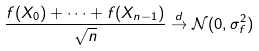<formula> <loc_0><loc_0><loc_500><loc_500>\frac { f ( X _ { 0 } ) + \dots + f ( X _ { n - 1 } ) } { \sqrt { n } } \stackrel { d } { \to } \mathcal { N } ( 0 , \sigma _ { f } ^ { 2 } )</formula> 